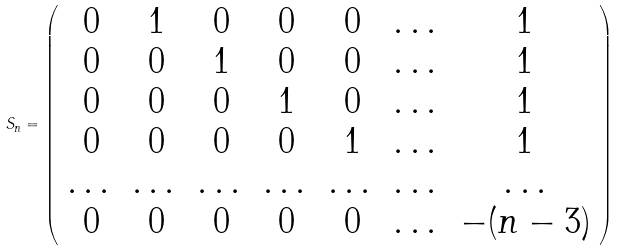<formula> <loc_0><loc_0><loc_500><loc_500>S _ { n } = \left ( \begin{array} { c c c c c c c } 0 & 1 & 0 & 0 & 0 & \dots & 1 \\ 0 & 0 & 1 & 0 & 0 & \dots & 1 \\ 0 & 0 & 0 & 1 & 0 & \dots & 1 \\ 0 & 0 & 0 & 0 & 1 & \dots & 1 \\ \dots & \dots & \dots & \dots & \dots & \dots & \dots \\ 0 & 0 & 0 & 0 & 0 & \dots & - ( n - 3 ) \end{array} \right )</formula> 